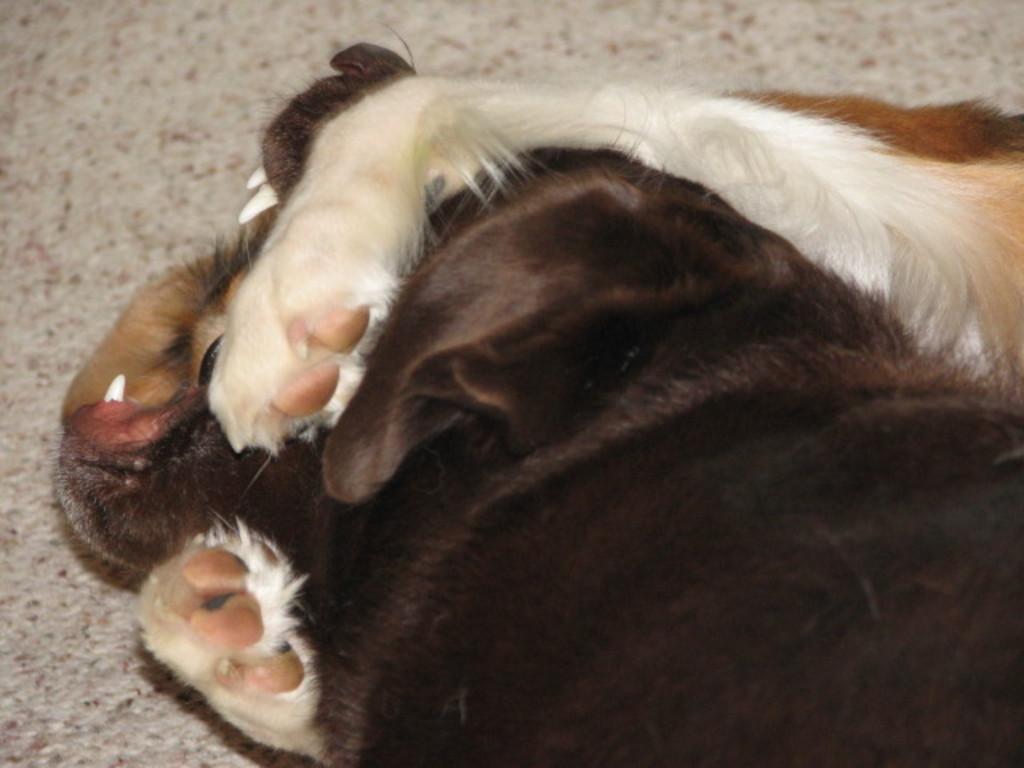Describe this image in one or two sentences. In this picture, we see two dogs in white and black color. In the background, we see the carpet or the floor in grey color. 